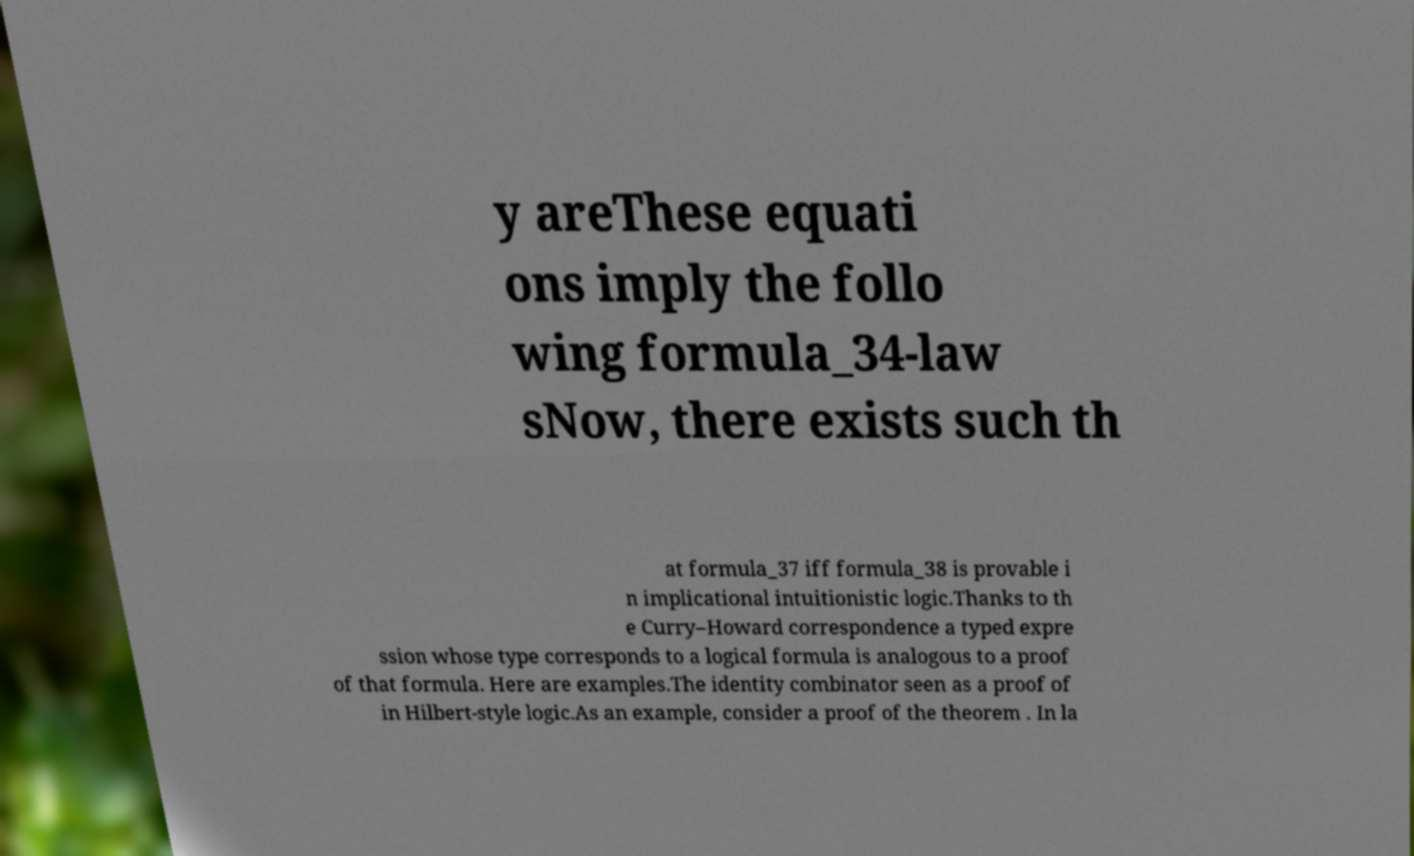For documentation purposes, I need the text within this image transcribed. Could you provide that? y areThese equati ons imply the follo wing formula_34-law sNow, there exists such th at formula_37 iff formula_38 is provable i n implicational intuitionistic logic.Thanks to th e Curry–Howard correspondence a typed expre ssion whose type corresponds to a logical formula is analogous to a proof of that formula. Here are examples.The identity combinator seen as a proof of in Hilbert-style logic.As an example, consider a proof of the theorem . In la 